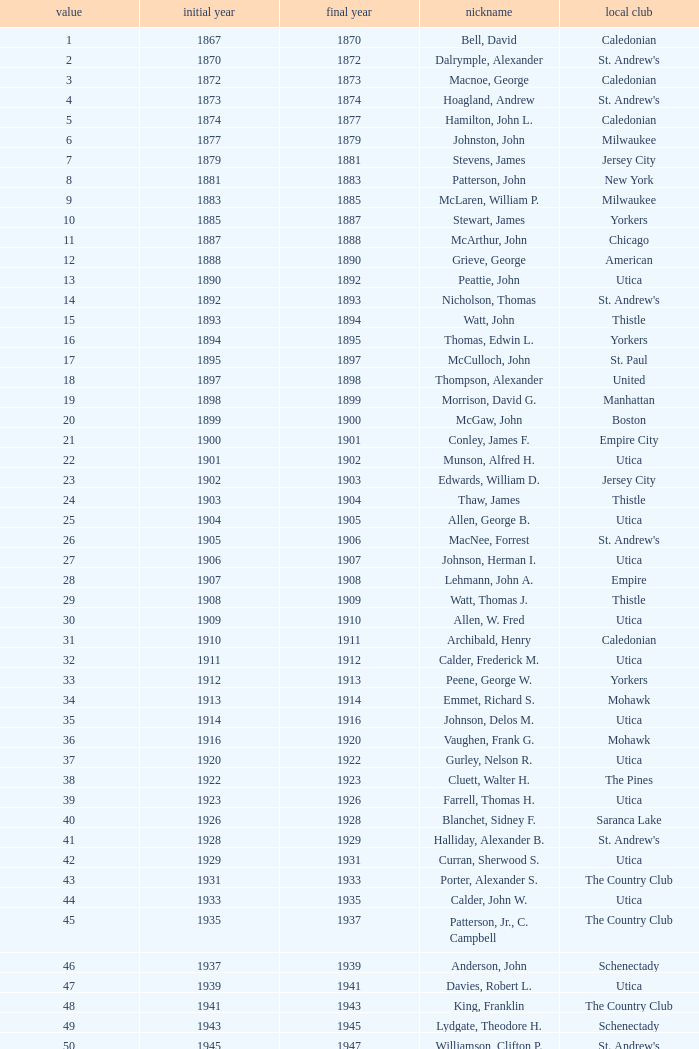Which Number has a Home Club of broomstones, and a Year End smaller than 1999? None. 